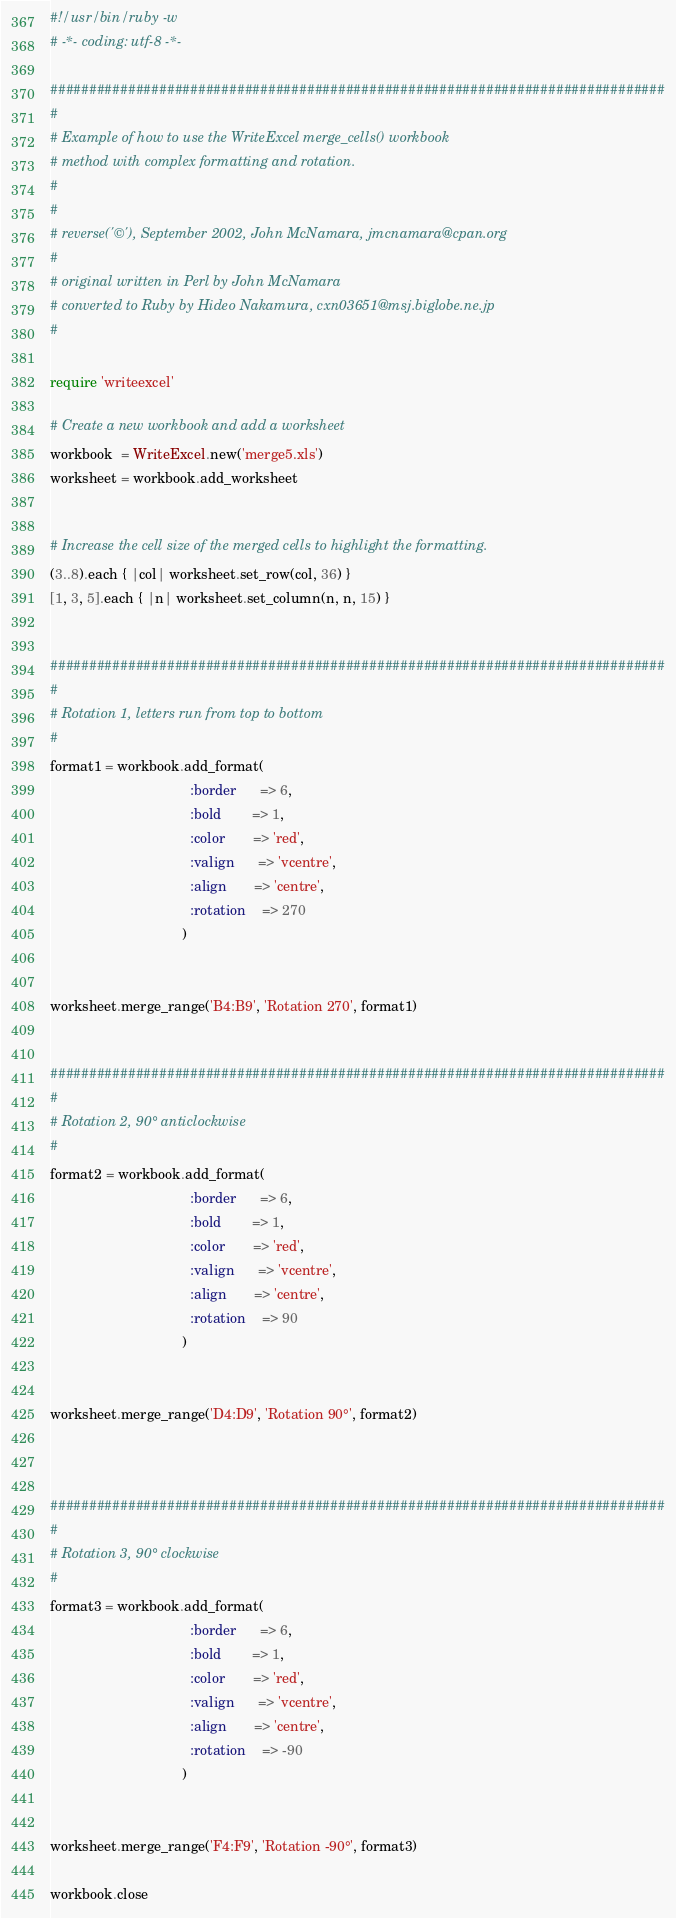<code> <loc_0><loc_0><loc_500><loc_500><_Ruby_>#!/usr/bin/ruby -w
# -*- coding: utf-8 -*-

###############################################################################
#
# Example of how to use the WriteExcel merge_cells() workbook
# method with complex formatting and rotation.
#
#
# reverse('©'), September 2002, John McNamara, jmcnamara@cpan.org
#
# original written in Perl by John McNamara
# converted to Ruby by Hideo Nakamura, cxn03651@msj.biglobe.ne.jp
#

require 'writeexcel'

# Create a new workbook and add a worksheet
workbook  = WriteExcel.new('merge5.xls')
worksheet = workbook.add_worksheet


# Increase the cell size of the merged cells to highlight the formatting.
(3..8).each { |col| worksheet.set_row(col, 36) }
[1, 3, 5].each { |n| worksheet.set_column(n, n, 15) }


###############################################################################
#
# Rotation 1, letters run from top to bottom
#
format1 = workbook.add_format(
                                    :border      => 6,
                                    :bold        => 1,
                                    :color       => 'red',
                                    :valign      => 'vcentre',
                                    :align       => 'centre',
                                    :rotation    => 270
                                  )


worksheet.merge_range('B4:B9', 'Rotation 270', format1)


###############################################################################
#
# Rotation 2, 90° anticlockwise
#
format2 = workbook.add_format(
                                    :border      => 6,
                                    :bold        => 1,
                                    :color       => 'red',
                                    :valign      => 'vcentre',
                                    :align       => 'centre',
                                    :rotation    => 90
                                  )


worksheet.merge_range('D4:D9', 'Rotation 90°', format2)



###############################################################################
#
# Rotation 3, 90° clockwise
#
format3 = workbook.add_format(
                                    :border      => 6,
                                    :bold        => 1,
                                    :color       => 'red',
                                    :valign      => 'vcentre',
                                    :align       => 'centre',
                                    :rotation    => -90
                                  )


worksheet.merge_range('F4:F9', 'Rotation -90°', format3)

workbook.close
</code> 